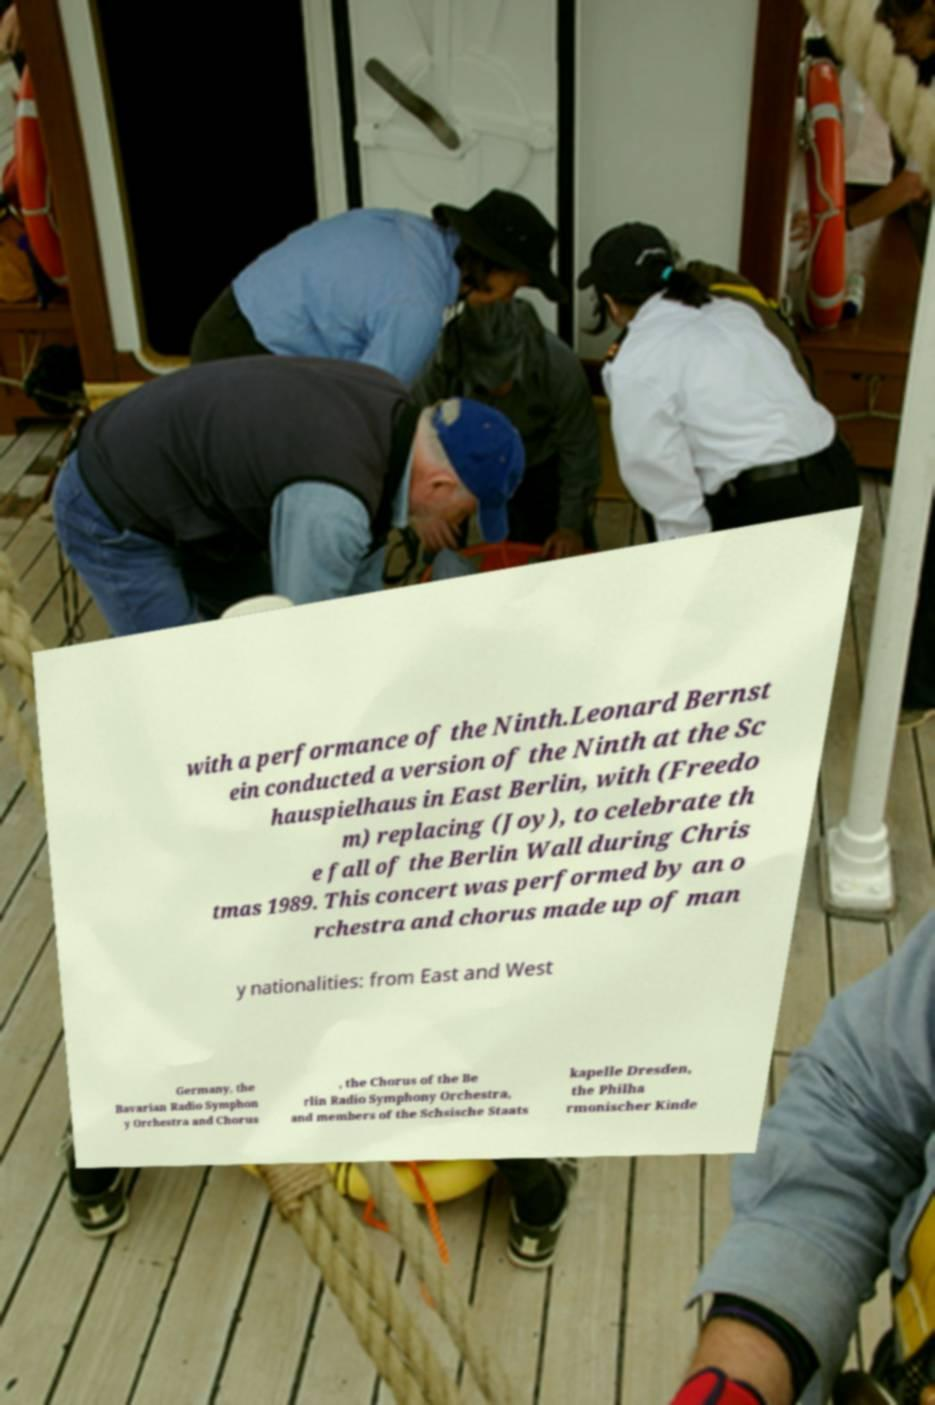Could you assist in decoding the text presented in this image and type it out clearly? with a performance of the Ninth.Leonard Bernst ein conducted a version of the Ninth at the Sc hauspielhaus in East Berlin, with (Freedo m) replacing (Joy), to celebrate th e fall of the Berlin Wall during Chris tmas 1989. This concert was performed by an o rchestra and chorus made up of man y nationalities: from East and West Germany, the Bavarian Radio Symphon y Orchestra and Chorus , the Chorus of the Be rlin Radio Symphony Orchestra, and members of the Schsische Staats kapelle Dresden, the Philha rmonischer Kinde 